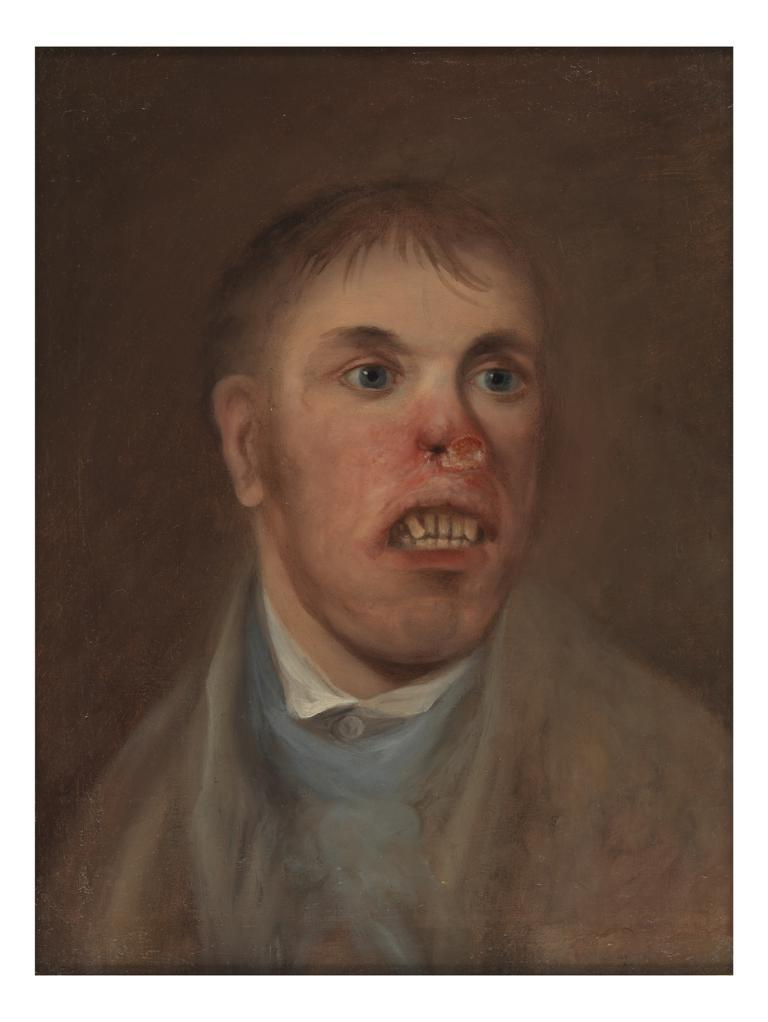What is the main subject of the painting in the image? There is a painting of a person in the image. How many pages are included in the painting in the image? There are no pages present in the painting; it is a painting of a person. Are there any spiders visible in the painting in the image? There are no spiders visible in the painting; it is a painting of a person. 